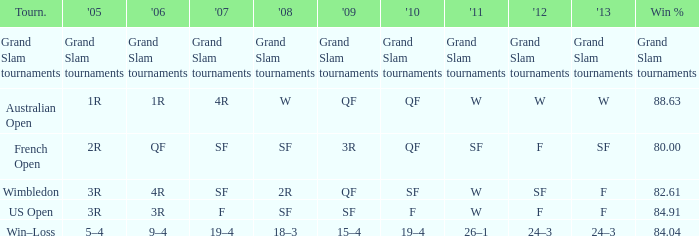What in 2007 has a 2008 of sf, and a 2010 of f? F. 